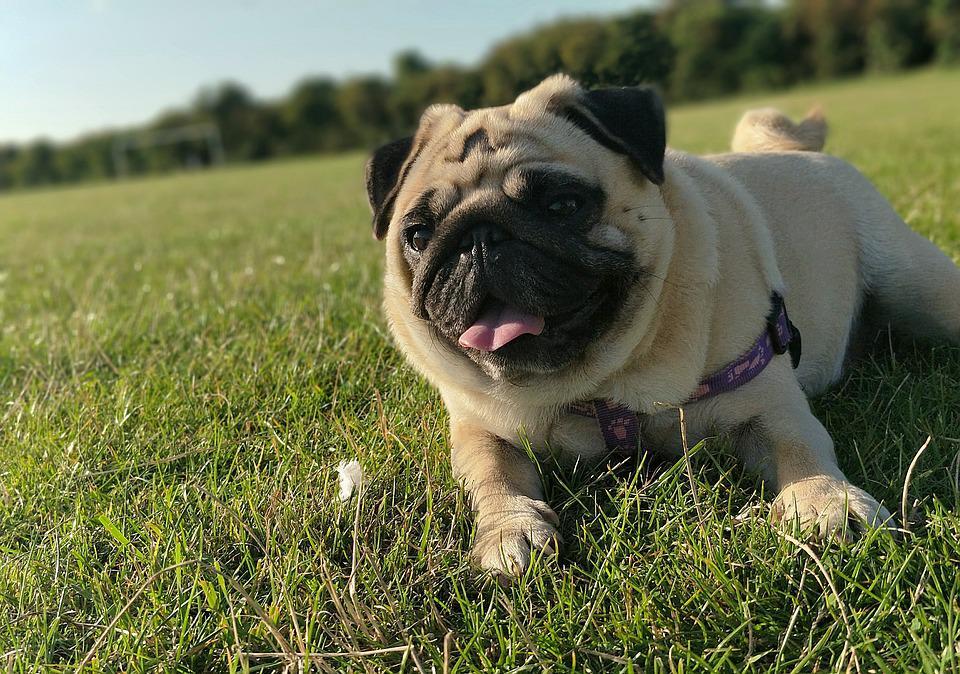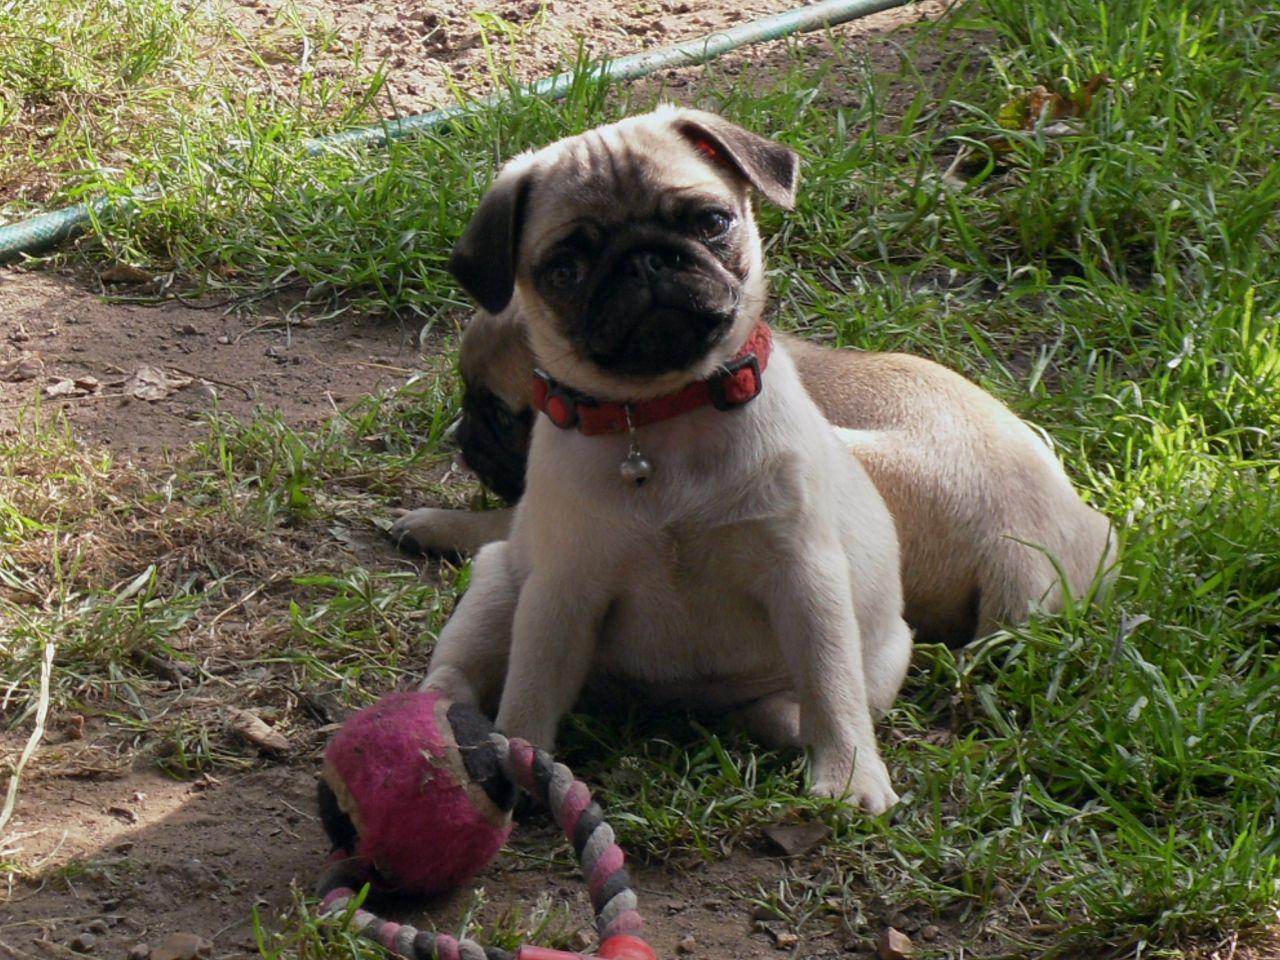The first image is the image on the left, the second image is the image on the right. Assess this claim about the two images: "There is a toy present with two dogs.". Correct or not? Answer yes or no. Yes. The first image is the image on the left, the second image is the image on the right. Examine the images to the left and right. Is the description "All the images show pugs that are tan." accurate? Answer yes or no. Yes. 